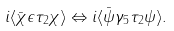Convert formula to latex. <formula><loc_0><loc_0><loc_500><loc_500>i \langle \bar { \chi } \epsilon \tau _ { 2 } \chi \rangle \Leftrightarrow i \langle \bar { \psi } \gamma _ { 5 } \tau _ { 2 } \psi \rangle .</formula> 